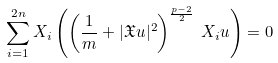Convert formula to latex. <formula><loc_0><loc_0><loc_500><loc_500>\sum _ { i = 1 } ^ { 2 n } X _ { i } \left ( \left ( \frac { 1 } { m } + | \mathfrak { X } u | ^ { 2 } \right ) ^ { \frac { p - 2 } { 2 } } \, X _ { i } u \right ) = 0</formula> 